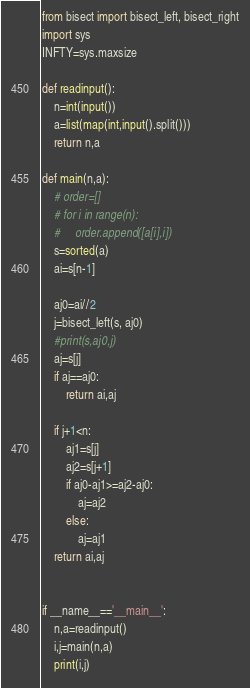<code> <loc_0><loc_0><loc_500><loc_500><_Python_>from bisect import bisect_left, bisect_right
import sys
INFTY=sys.maxsize

def readinput():
    n=int(input())
    a=list(map(int,input().split()))
    return n,a

def main(n,a):
    # order=[]
    # for i in range(n):
    #     order.append([a[i],i])
    s=sorted(a)
    ai=s[n-1]

    aj0=ai//2
    j=bisect_left(s, aj0)
    #print(s,aj0,j) 
    aj=s[j]
    if aj==aj0:
        return ai,aj

    if j+1<n:
        aj1=s[j]
        aj2=s[j+1]
        if aj0-aj1>=aj2-aj0:
            aj=aj2
        else:
            aj=aj1
    return ai,aj


if __name__=='__main__':
    n,a=readinput()
    i,j=main(n,a)
    print(i,j)
</code> 